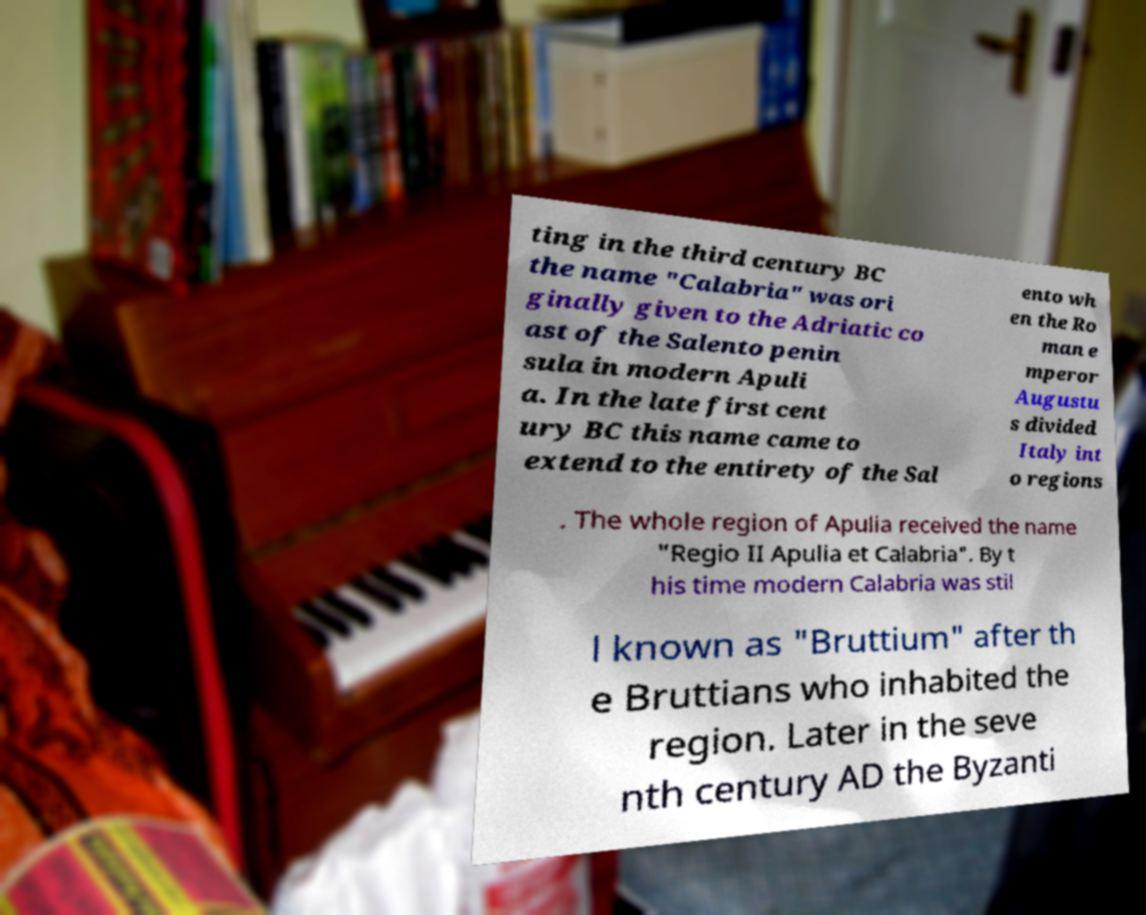Please identify and transcribe the text found in this image. ting in the third century BC the name "Calabria" was ori ginally given to the Adriatic co ast of the Salento penin sula in modern Apuli a. In the late first cent ury BC this name came to extend to the entirety of the Sal ento wh en the Ro man e mperor Augustu s divided Italy int o regions . The whole region of Apulia received the name "Regio II Apulia et Calabria". By t his time modern Calabria was stil l known as "Bruttium" after th e Bruttians who inhabited the region. Later in the seve nth century AD the Byzanti 